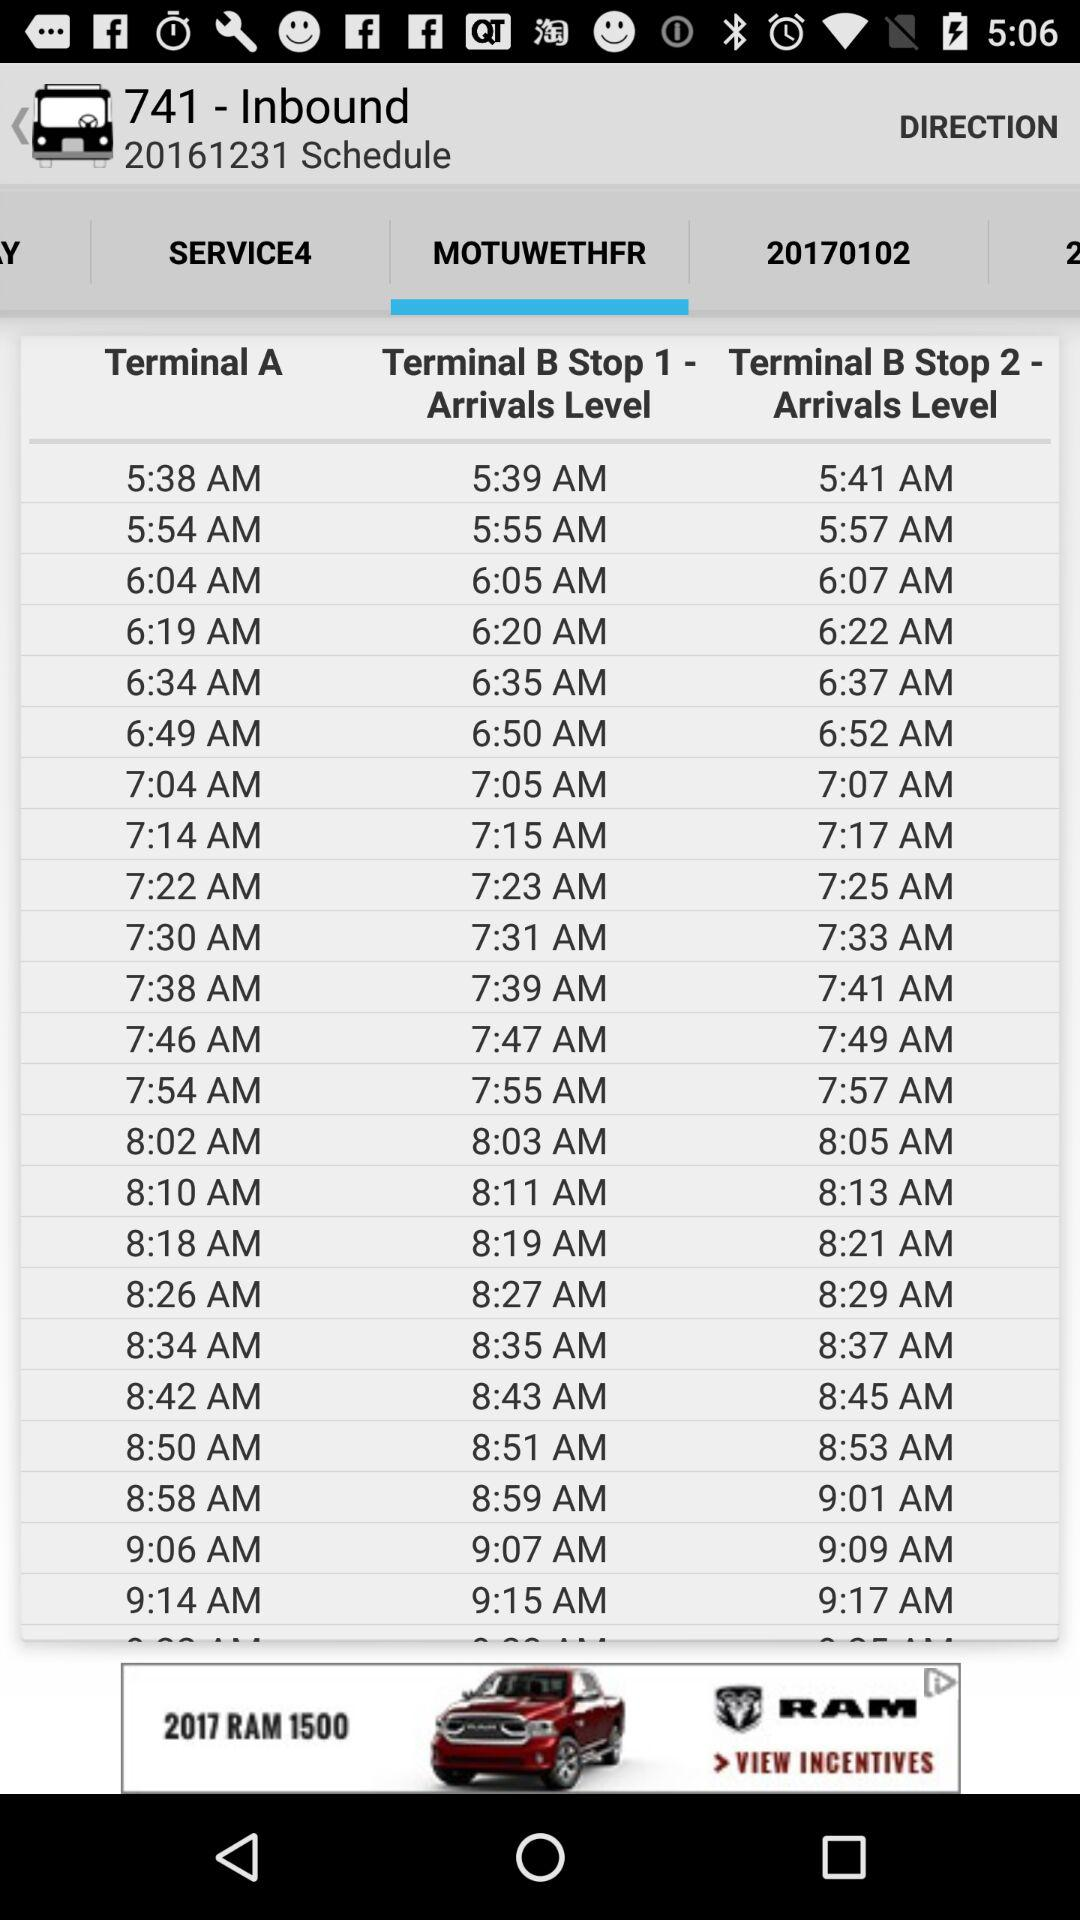What is the starting time of terminal A?
When the provided information is insufficient, respond with <no answer>. <no answer> 